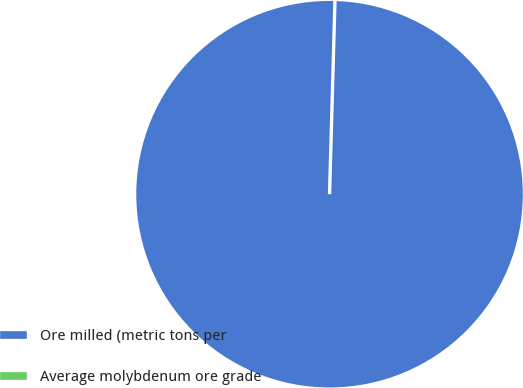<chart> <loc_0><loc_0><loc_500><loc_500><pie_chart><fcel>Ore milled (metric tons per<fcel>Average molybdenum ore grade<nl><fcel>100.0%<fcel>0.0%<nl></chart> 